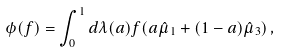Convert formula to latex. <formula><loc_0><loc_0><loc_500><loc_500>\phi ( f ) = \int _ { 0 } ^ { 1 } d \lambda ( a ) f ( a \hat { \mu } _ { 1 } + ( 1 - a ) \hat { \mu } _ { 3 } ) \, ,</formula> 